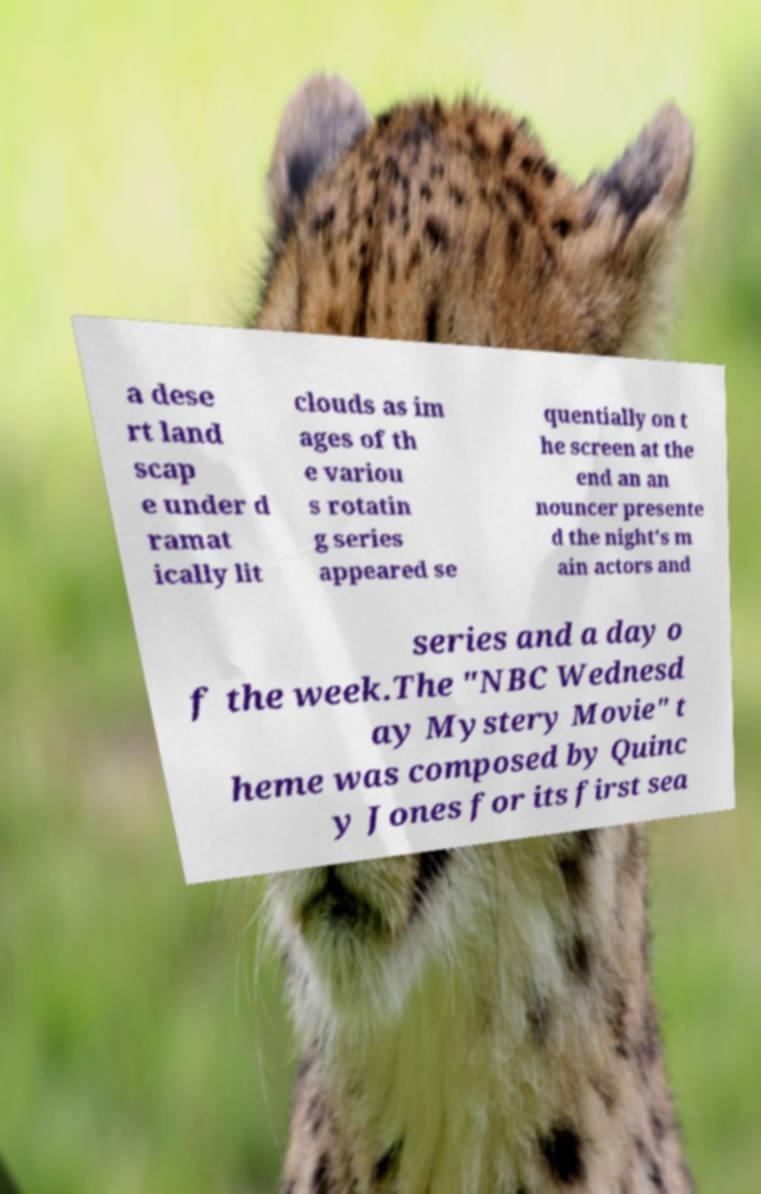Can you accurately transcribe the text from the provided image for me? a dese rt land scap e under d ramat ically lit clouds as im ages of th e variou s rotatin g series appeared se quentially on t he screen at the end an an nouncer presente d the night's m ain actors and series and a day o f the week.The "NBC Wednesd ay Mystery Movie" t heme was composed by Quinc y Jones for its first sea 